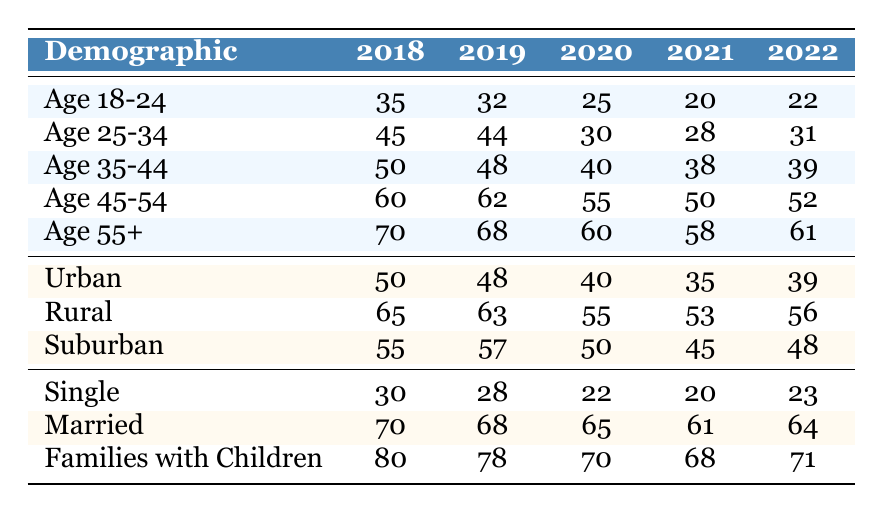What was the church attendance for the Age 25-34 group in 2020? The attendance for the Age 25-34 group in 2020 is found directly in the table under the 2020 column for the Age 25-34 demographic, which shows 30.
Answer: 30 Which demographic group had the highest attendance in 2018? In 2018, the table shows that Families with Children had the highest attendance at 80, compared to other groups listed.
Answer: Families with Children What is the average church attendance for the Age 55+ demographic over the five years? To find the average attendance, sum the attendance values for the Age 55+ group: (70 + 68 + 60 + 58 + 61) = 317. Then divide by the number of years (5), giving 317/5 = 63.4.
Answer: 63.4 Did the attendance for the Urban demographic increase from 2021 to 2022? The attendance for Urban was 35 in 2021 and 39 in 2022. Since 39 is greater than 35, the attendance did increase.
Answer: Yes What is the difference in attendance between Age 18-24 and Age 45-54 demographics in 2021? Attendance for Age 18-24 in 2021 is 20 and for Age 45-54 is 50. The difference is calculated as 50 - 20 = 30.
Answer: 30 What demographic group had the most consistent attendance (smallest fluctuations) between 2018 and 2022? By analyzing the differences in attendance year over year for each demographic, the Age 45-54 group shows the least variability (12 total change from 60 to 52).
Answer: Age 45-54 How much did the attendance for Single people decrease from 2018 to 2020? Single attendance in 2018 was 30 and decreased to 22 in 2020. The decrease is calculated as 30 - 22 = 8.
Answer: 8 Which year saw the highest recorded attendance for Rural demographic group? By examining the data, the Rural group's highest attendance is 65 in 2018, as all other years show lower numbers.
Answer: 2018 In which year did families with children see the least attendance? The attendance for Families with Children was lowest in 2021, when attendance dropped to 68, lower than previous years listed.
Answer: 2021 What was the percentage change in attendance for Married couples from 2018 to 2022? Attendance for Married couples in 2018 was 70, and in 2022 it was 64. The change is calculated as ((64 - 70)/70) * 100 = -8.57%.
Answer: -8.57% 